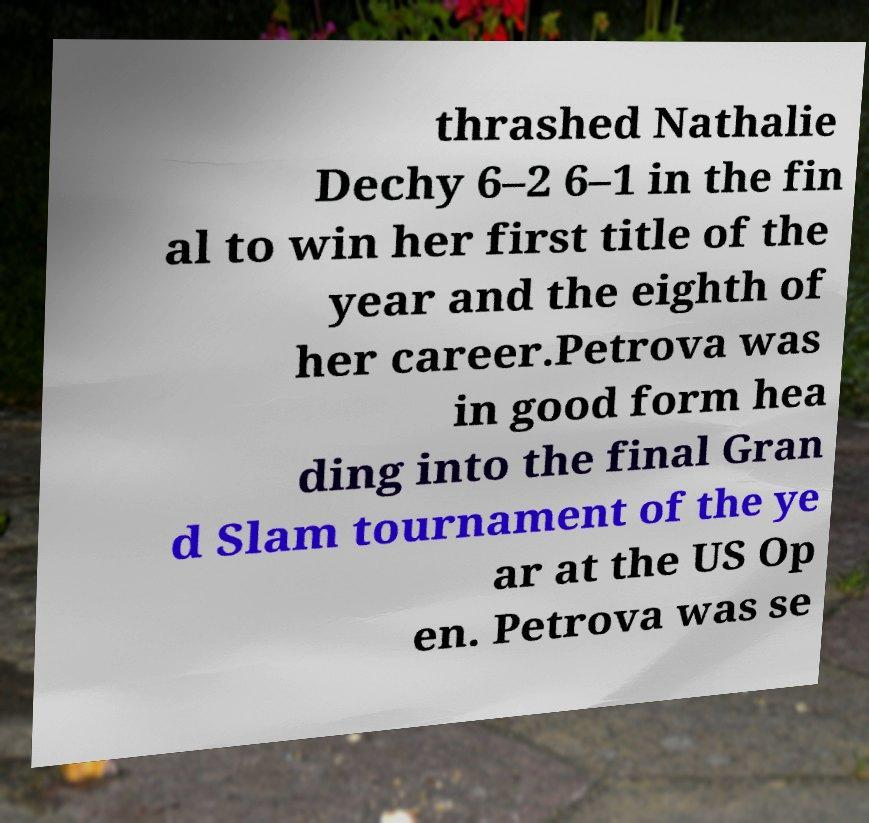Can you read and provide the text displayed in the image?This photo seems to have some interesting text. Can you extract and type it out for me? thrashed Nathalie Dechy 6–2 6–1 in the fin al to win her first title of the year and the eighth of her career.Petrova was in good form hea ding into the final Gran d Slam tournament of the ye ar at the US Op en. Petrova was se 